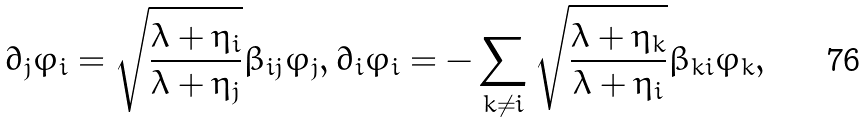Convert formula to latex. <formula><loc_0><loc_0><loc_500><loc_500>\partial _ { j } \varphi _ { i } = \sqrt { \frac { \lambda + \eta _ { i } } { \lambda + \eta _ { j } } } \beta _ { i j } \varphi _ { j } , \partial _ { i } \varphi _ { i } = - \sum _ { k \ne i } \sqrt { \frac { \lambda + \eta _ { k } } { \lambda + \eta _ { i } } } \beta _ { k i } \varphi _ { k } ,</formula> 